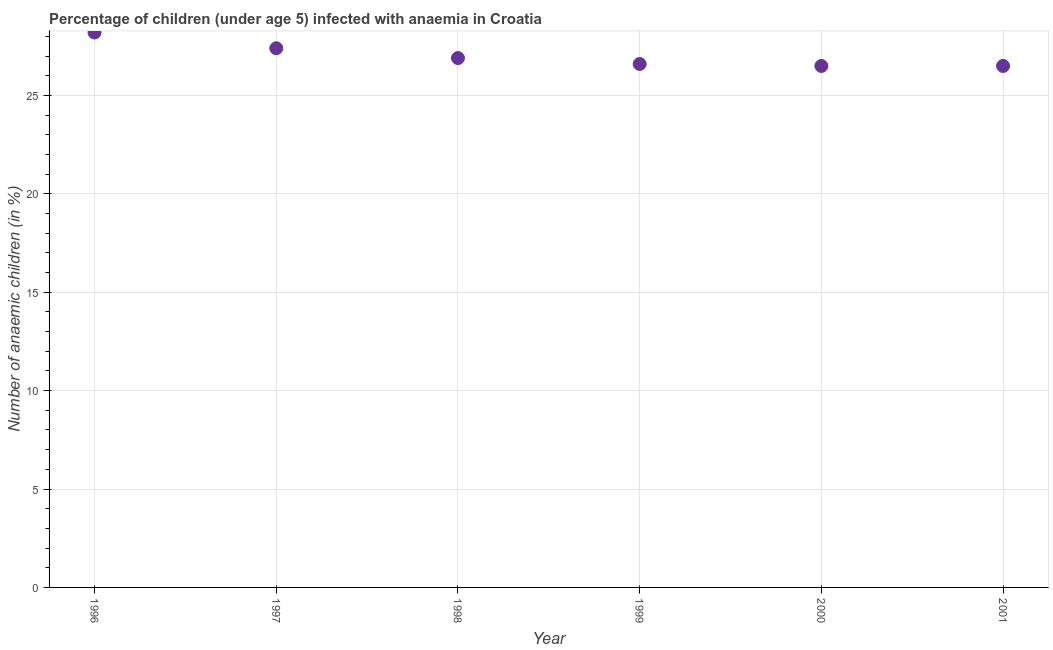Across all years, what is the maximum number of anaemic children?
Ensure brevity in your answer.  28.2. Across all years, what is the minimum number of anaemic children?
Give a very brief answer. 26.5. In which year was the number of anaemic children maximum?
Provide a succinct answer. 1996. In which year was the number of anaemic children minimum?
Provide a short and direct response. 2000. What is the sum of the number of anaemic children?
Offer a terse response. 162.1. What is the difference between the number of anaemic children in 1998 and 1999?
Make the answer very short. 0.3. What is the average number of anaemic children per year?
Offer a very short reply. 27.02. What is the median number of anaemic children?
Make the answer very short. 26.75. In how many years, is the number of anaemic children greater than 8 %?
Ensure brevity in your answer.  6. What is the ratio of the number of anaemic children in 1996 to that in 1998?
Provide a succinct answer. 1.05. What is the difference between the highest and the second highest number of anaemic children?
Keep it short and to the point. 0.8. Is the sum of the number of anaemic children in 1996 and 1999 greater than the maximum number of anaemic children across all years?
Ensure brevity in your answer.  Yes. What is the difference between the highest and the lowest number of anaemic children?
Make the answer very short. 1.7. In how many years, is the number of anaemic children greater than the average number of anaemic children taken over all years?
Provide a short and direct response. 2. Does the number of anaemic children monotonically increase over the years?
Your response must be concise. No. What is the difference between two consecutive major ticks on the Y-axis?
Offer a terse response. 5. Are the values on the major ticks of Y-axis written in scientific E-notation?
Make the answer very short. No. Does the graph contain any zero values?
Your answer should be compact. No. Does the graph contain grids?
Provide a short and direct response. Yes. What is the title of the graph?
Provide a succinct answer. Percentage of children (under age 5) infected with anaemia in Croatia. What is the label or title of the Y-axis?
Offer a very short reply. Number of anaemic children (in %). What is the Number of anaemic children (in %) in 1996?
Your response must be concise. 28.2. What is the Number of anaemic children (in %) in 1997?
Give a very brief answer. 27.4. What is the Number of anaemic children (in %) in 1998?
Keep it short and to the point. 26.9. What is the Number of anaemic children (in %) in 1999?
Give a very brief answer. 26.6. What is the Number of anaemic children (in %) in 2000?
Keep it short and to the point. 26.5. What is the Number of anaemic children (in %) in 2001?
Offer a terse response. 26.5. What is the difference between the Number of anaemic children (in %) in 1996 and 1997?
Provide a short and direct response. 0.8. What is the difference between the Number of anaemic children (in %) in 1996 and 1998?
Make the answer very short. 1.3. What is the difference between the Number of anaemic children (in %) in 1996 and 2000?
Give a very brief answer. 1.7. What is the difference between the Number of anaemic children (in %) in 1997 and 1999?
Your answer should be compact. 0.8. What is the difference between the Number of anaemic children (in %) in 1997 and 2000?
Provide a succinct answer. 0.9. What is the difference between the Number of anaemic children (in %) in 2000 and 2001?
Make the answer very short. 0. What is the ratio of the Number of anaemic children (in %) in 1996 to that in 1998?
Your answer should be very brief. 1.05. What is the ratio of the Number of anaemic children (in %) in 1996 to that in 1999?
Keep it short and to the point. 1.06. What is the ratio of the Number of anaemic children (in %) in 1996 to that in 2000?
Offer a terse response. 1.06. What is the ratio of the Number of anaemic children (in %) in 1996 to that in 2001?
Give a very brief answer. 1.06. What is the ratio of the Number of anaemic children (in %) in 1997 to that in 2000?
Provide a succinct answer. 1.03. What is the ratio of the Number of anaemic children (in %) in 1997 to that in 2001?
Give a very brief answer. 1.03. What is the ratio of the Number of anaemic children (in %) in 1998 to that in 1999?
Offer a very short reply. 1.01. What is the ratio of the Number of anaemic children (in %) in 1998 to that in 2000?
Keep it short and to the point. 1.01. What is the ratio of the Number of anaemic children (in %) in 1998 to that in 2001?
Keep it short and to the point. 1.01. What is the ratio of the Number of anaemic children (in %) in 1999 to that in 2001?
Your response must be concise. 1. What is the ratio of the Number of anaemic children (in %) in 2000 to that in 2001?
Give a very brief answer. 1. 